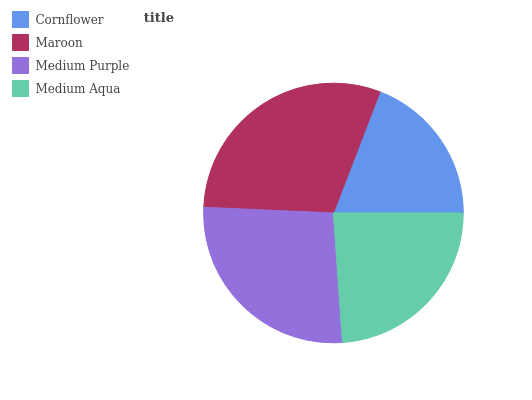Is Cornflower the minimum?
Answer yes or no. Yes. Is Maroon the maximum?
Answer yes or no. Yes. Is Medium Purple the minimum?
Answer yes or no. No. Is Medium Purple the maximum?
Answer yes or no. No. Is Maroon greater than Medium Purple?
Answer yes or no. Yes. Is Medium Purple less than Maroon?
Answer yes or no. Yes. Is Medium Purple greater than Maroon?
Answer yes or no. No. Is Maroon less than Medium Purple?
Answer yes or no. No. Is Medium Purple the high median?
Answer yes or no. Yes. Is Medium Aqua the low median?
Answer yes or no. Yes. Is Cornflower the high median?
Answer yes or no. No. Is Medium Purple the low median?
Answer yes or no. No. 